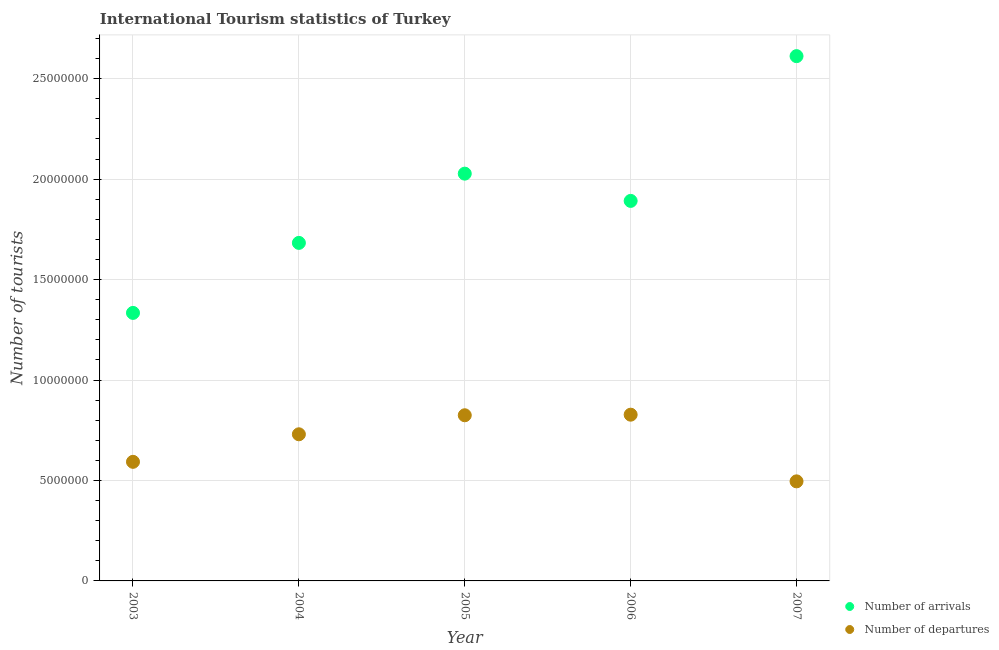How many different coloured dotlines are there?
Make the answer very short. 2. Is the number of dotlines equal to the number of legend labels?
Offer a terse response. Yes. What is the number of tourist departures in 2003?
Provide a short and direct response. 5.93e+06. Across all years, what is the maximum number of tourist departures?
Ensure brevity in your answer.  8.28e+06. Across all years, what is the minimum number of tourist arrivals?
Provide a succinct answer. 1.33e+07. In which year was the number of tourist departures maximum?
Provide a short and direct response. 2006. What is the total number of tourist departures in the graph?
Provide a short and direct response. 3.47e+07. What is the difference between the number of tourist arrivals in 2003 and that in 2007?
Provide a succinct answer. -1.28e+07. What is the difference between the number of tourist departures in 2006 and the number of tourist arrivals in 2004?
Make the answer very short. -8.55e+06. What is the average number of tourist arrivals per year?
Offer a very short reply. 1.91e+07. In the year 2005, what is the difference between the number of tourist arrivals and number of tourist departures?
Your response must be concise. 1.20e+07. What is the ratio of the number of tourist departures in 2003 to that in 2007?
Make the answer very short. 1.2. Is the number of tourist departures in 2005 less than that in 2007?
Provide a short and direct response. No. Is the difference between the number of tourist departures in 2004 and 2005 greater than the difference between the number of tourist arrivals in 2004 and 2005?
Your response must be concise. Yes. What is the difference between the highest and the second highest number of tourist arrivals?
Provide a succinct answer. 5.85e+06. What is the difference between the highest and the lowest number of tourist arrivals?
Provide a succinct answer. 1.28e+07. In how many years, is the number of tourist departures greater than the average number of tourist departures taken over all years?
Offer a terse response. 3. Does the number of tourist arrivals monotonically increase over the years?
Make the answer very short. No. How many dotlines are there?
Provide a succinct answer. 2. Does the graph contain any zero values?
Provide a succinct answer. No. How many legend labels are there?
Ensure brevity in your answer.  2. How are the legend labels stacked?
Your answer should be compact. Vertical. What is the title of the graph?
Offer a very short reply. International Tourism statistics of Turkey. Does "From Government" appear as one of the legend labels in the graph?
Make the answer very short. No. What is the label or title of the Y-axis?
Keep it short and to the point. Number of tourists. What is the Number of tourists of Number of arrivals in 2003?
Your answer should be very brief. 1.33e+07. What is the Number of tourists of Number of departures in 2003?
Your response must be concise. 5.93e+06. What is the Number of tourists in Number of arrivals in 2004?
Your answer should be very brief. 1.68e+07. What is the Number of tourists in Number of departures in 2004?
Provide a short and direct response. 7.30e+06. What is the Number of tourists in Number of arrivals in 2005?
Your answer should be compact. 2.03e+07. What is the Number of tourists in Number of departures in 2005?
Provide a succinct answer. 8.25e+06. What is the Number of tourists of Number of arrivals in 2006?
Your response must be concise. 1.89e+07. What is the Number of tourists in Number of departures in 2006?
Keep it short and to the point. 8.28e+06. What is the Number of tourists in Number of arrivals in 2007?
Provide a succinct answer. 2.61e+07. What is the Number of tourists in Number of departures in 2007?
Your response must be concise. 4.96e+06. Across all years, what is the maximum Number of tourists of Number of arrivals?
Offer a very short reply. 2.61e+07. Across all years, what is the maximum Number of tourists in Number of departures?
Your response must be concise. 8.28e+06. Across all years, what is the minimum Number of tourists in Number of arrivals?
Your answer should be compact. 1.33e+07. Across all years, what is the minimum Number of tourists of Number of departures?
Your answer should be very brief. 4.96e+06. What is the total Number of tourists of Number of arrivals in the graph?
Give a very brief answer. 9.55e+07. What is the total Number of tourists of Number of departures in the graph?
Provide a short and direct response. 3.47e+07. What is the difference between the Number of tourists in Number of arrivals in 2003 and that in 2004?
Ensure brevity in your answer.  -3.48e+06. What is the difference between the Number of tourists of Number of departures in 2003 and that in 2004?
Give a very brief answer. -1.37e+06. What is the difference between the Number of tourists in Number of arrivals in 2003 and that in 2005?
Provide a short and direct response. -6.93e+06. What is the difference between the Number of tourists of Number of departures in 2003 and that in 2005?
Provide a short and direct response. -2.32e+06. What is the difference between the Number of tourists in Number of arrivals in 2003 and that in 2006?
Give a very brief answer. -5.58e+06. What is the difference between the Number of tourists of Number of departures in 2003 and that in 2006?
Ensure brevity in your answer.  -2.35e+06. What is the difference between the Number of tourists in Number of arrivals in 2003 and that in 2007?
Ensure brevity in your answer.  -1.28e+07. What is the difference between the Number of tourists in Number of departures in 2003 and that in 2007?
Provide a short and direct response. 9.72e+05. What is the difference between the Number of tourists of Number of arrivals in 2004 and that in 2005?
Keep it short and to the point. -3.45e+06. What is the difference between the Number of tourists in Number of departures in 2004 and that in 2005?
Give a very brief answer. -9.47e+05. What is the difference between the Number of tourists of Number of arrivals in 2004 and that in 2006?
Offer a terse response. -2.09e+06. What is the difference between the Number of tourists in Number of departures in 2004 and that in 2006?
Your response must be concise. -9.76e+05. What is the difference between the Number of tourists of Number of arrivals in 2004 and that in 2007?
Your response must be concise. -9.30e+06. What is the difference between the Number of tourists of Number of departures in 2004 and that in 2007?
Give a very brief answer. 2.34e+06. What is the difference between the Number of tourists of Number of arrivals in 2005 and that in 2006?
Provide a succinct answer. 1.36e+06. What is the difference between the Number of tourists of Number of departures in 2005 and that in 2006?
Your answer should be compact. -2.90e+04. What is the difference between the Number of tourists of Number of arrivals in 2005 and that in 2007?
Offer a very short reply. -5.85e+06. What is the difference between the Number of tourists in Number of departures in 2005 and that in 2007?
Your answer should be very brief. 3.29e+06. What is the difference between the Number of tourists in Number of arrivals in 2006 and that in 2007?
Make the answer very short. -7.21e+06. What is the difference between the Number of tourists of Number of departures in 2006 and that in 2007?
Make the answer very short. 3.32e+06. What is the difference between the Number of tourists in Number of arrivals in 2003 and the Number of tourists in Number of departures in 2004?
Offer a very short reply. 6.04e+06. What is the difference between the Number of tourists in Number of arrivals in 2003 and the Number of tourists in Number of departures in 2005?
Offer a terse response. 5.10e+06. What is the difference between the Number of tourists of Number of arrivals in 2003 and the Number of tourists of Number of departures in 2006?
Offer a very short reply. 5.07e+06. What is the difference between the Number of tourists of Number of arrivals in 2003 and the Number of tourists of Number of departures in 2007?
Your answer should be compact. 8.38e+06. What is the difference between the Number of tourists in Number of arrivals in 2004 and the Number of tourists in Number of departures in 2005?
Provide a succinct answer. 8.58e+06. What is the difference between the Number of tourists of Number of arrivals in 2004 and the Number of tourists of Number of departures in 2006?
Give a very brief answer. 8.55e+06. What is the difference between the Number of tourists of Number of arrivals in 2004 and the Number of tourists of Number of departures in 2007?
Provide a short and direct response. 1.19e+07. What is the difference between the Number of tourists in Number of arrivals in 2005 and the Number of tourists in Number of departures in 2006?
Your answer should be compact. 1.20e+07. What is the difference between the Number of tourists in Number of arrivals in 2005 and the Number of tourists in Number of departures in 2007?
Your response must be concise. 1.53e+07. What is the difference between the Number of tourists in Number of arrivals in 2006 and the Number of tourists in Number of departures in 2007?
Provide a short and direct response. 1.40e+07. What is the average Number of tourists in Number of arrivals per year?
Provide a succinct answer. 1.91e+07. What is the average Number of tourists in Number of departures per year?
Provide a short and direct response. 6.94e+06. In the year 2003, what is the difference between the Number of tourists of Number of arrivals and Number of tourists of Number of departures?
Ensure brevity in your answer.  7.41e+06. In the year 2004, what is the difference between the Number of tourists in Number of arrivals and Number of tourists in Number of departures?
Ensure brevity in your answer.  9.53e+06. In the year 2005, what is the difference between the Number of tourists in Number of arrivals and Number of tourists in Number of departures?
Offer a very short reply. 1.20e+07. In the year 2006, what is the difference between the Number of tourists in Number of arrivals and Number of tourists in Number of departures?
Your answer should be very brief. 1.06e+07. In the year 2007, what is the difference between the Number of tourists of Number of arrivals and Number of tourists of Number of departures?
Provide a short and direct response. 2.12e+07. What is the ratio of the Number of tourists of Number of arrivals in 2003 to that in 2004?
Provide a short and direct response. 0.79. What is the ratio of the Number of tourists of Number of departures in 2003 to that in 2004?
Offer a very short reply. 0.81. What is the ratio of the Number of tourists in Number of arrivals in 2003 to that in 2005?
Make the answer very short. 0.66. What is the ratio of the Number of tourists of Number of departures in 2003 to that in 2005?
Your answer should be compact. 0.72. What is the ratio of the Number of tourists of Number of arrivals in 2003 to that in 2006?
Your answer should be very brief. 0.71. What is the ratio of the Number of tourists of Number of departures in 2003 to that in 2006?
Provide a short and direct response. 0.72. What is the ratio of the Number of tourists in Number of arrivals in 2003 to that in 2007?
Offer a terse response. 0.51. What is the ratio of the Number of tourists in Number of departures in 2003 to that in 2007?
Offer a terse response. 1.2. What is the ratio of the Number of tourists in Number of arrivals in 2004 to that in 2005?
Provide a succinct answer. 0.83. What is the ratio of the Number of tourists in Number of departures in 2004 to that in 2005?
Your response must be concise. 0.89. What is the ratio of the Number of tourists of Number of arrivals in 2004 to that in 2006?
Give a very brief answer. 0.89. What is the ratio of the Number of tourists of Number of departures in 2004 to that in 2006?
Offer a terse response. 0.88. What is the ratio of the Number of tourists of Number of arrivals in 2004 to that in 2007?
Your answer should be very brief. 0.64. What is the ratio of the Number of tourists in Number of departures in 2004 to that in 2007?
Your answer should be very brief. 1.47. What is the ratio of the Number of tourists in Number of arrivals in 2005 to that in 2006?
Provide a short and direct response. 1.07. What is the ratio of the Number of tourists of Number of arrivals in 2005 to that in 2007?
Ensure brevity in your answer.  0.78. What is the ratio of the Number of tourists in Number of departures in 2005 to that in 2007?
Make the answer very short. 1.66. What is the ratio of the Number of tourists of Number of arrivals in 2006 to that in 2007?
Offer a very short reply. 0.72. What is the ratio of the Number of tourists in Number of departures in 2006 to that in 2007?
Provide a short and direct response. 1.67. What is the difference between the highest and the second highest Number of tourists of Number of arrivals?
Ensure brevity in your answer.  5.85e+06. What is the difference between the highest and the second highest Number of tourists in Number of departures?
Offer a very short reply. 2.90e+04. What is the difference between the highest and the lowest Number of tourists of Number of arrivals?
Make the answer very short. 1.28e+07. What is the difference between the highest and the lowest Number of tourists in Number of departures?
Offer a terse response. 3.32e+06. 